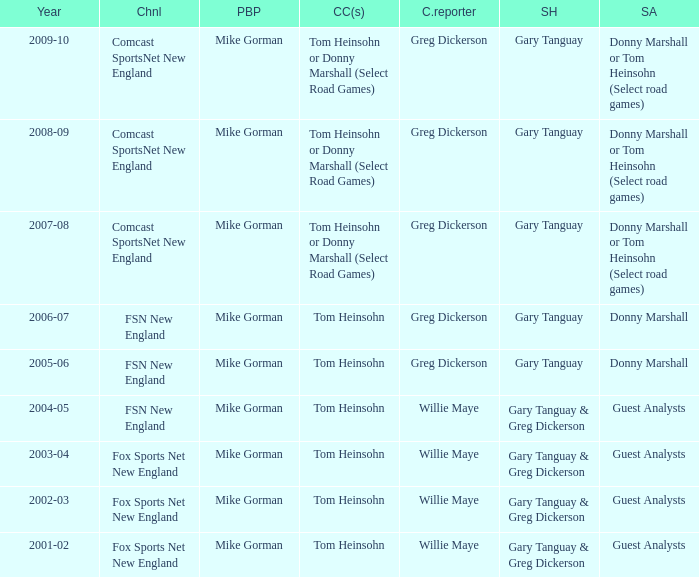Who is the courtside reporter for the year 2009-10? Greg Dickerson. 